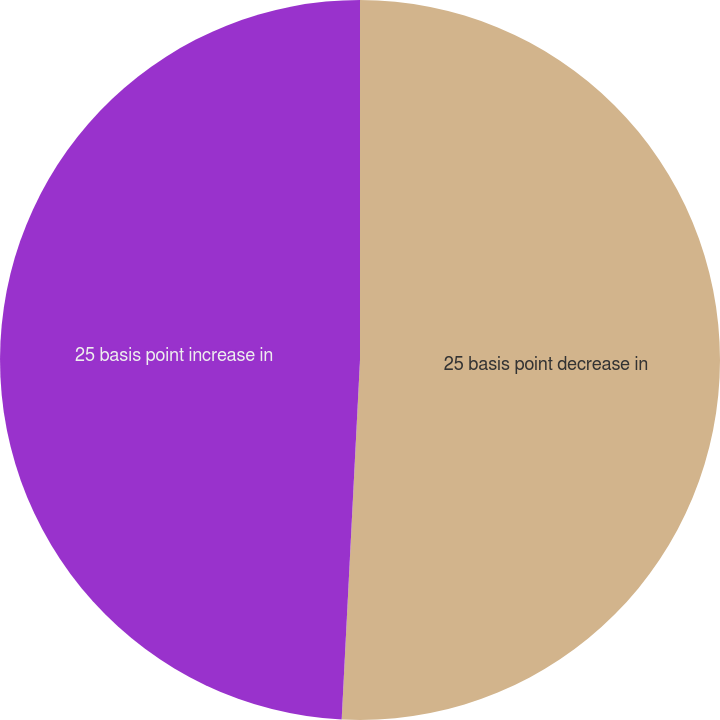Convert chart to OTSL. <chart><loc_0><loc_0><loc_500><loc_500><pie_chart><fcel>25 basis point decrease in<fcel>25 basis point increase in<nl><fcel>50.81%<fcel>49.19%<nl></chart> 